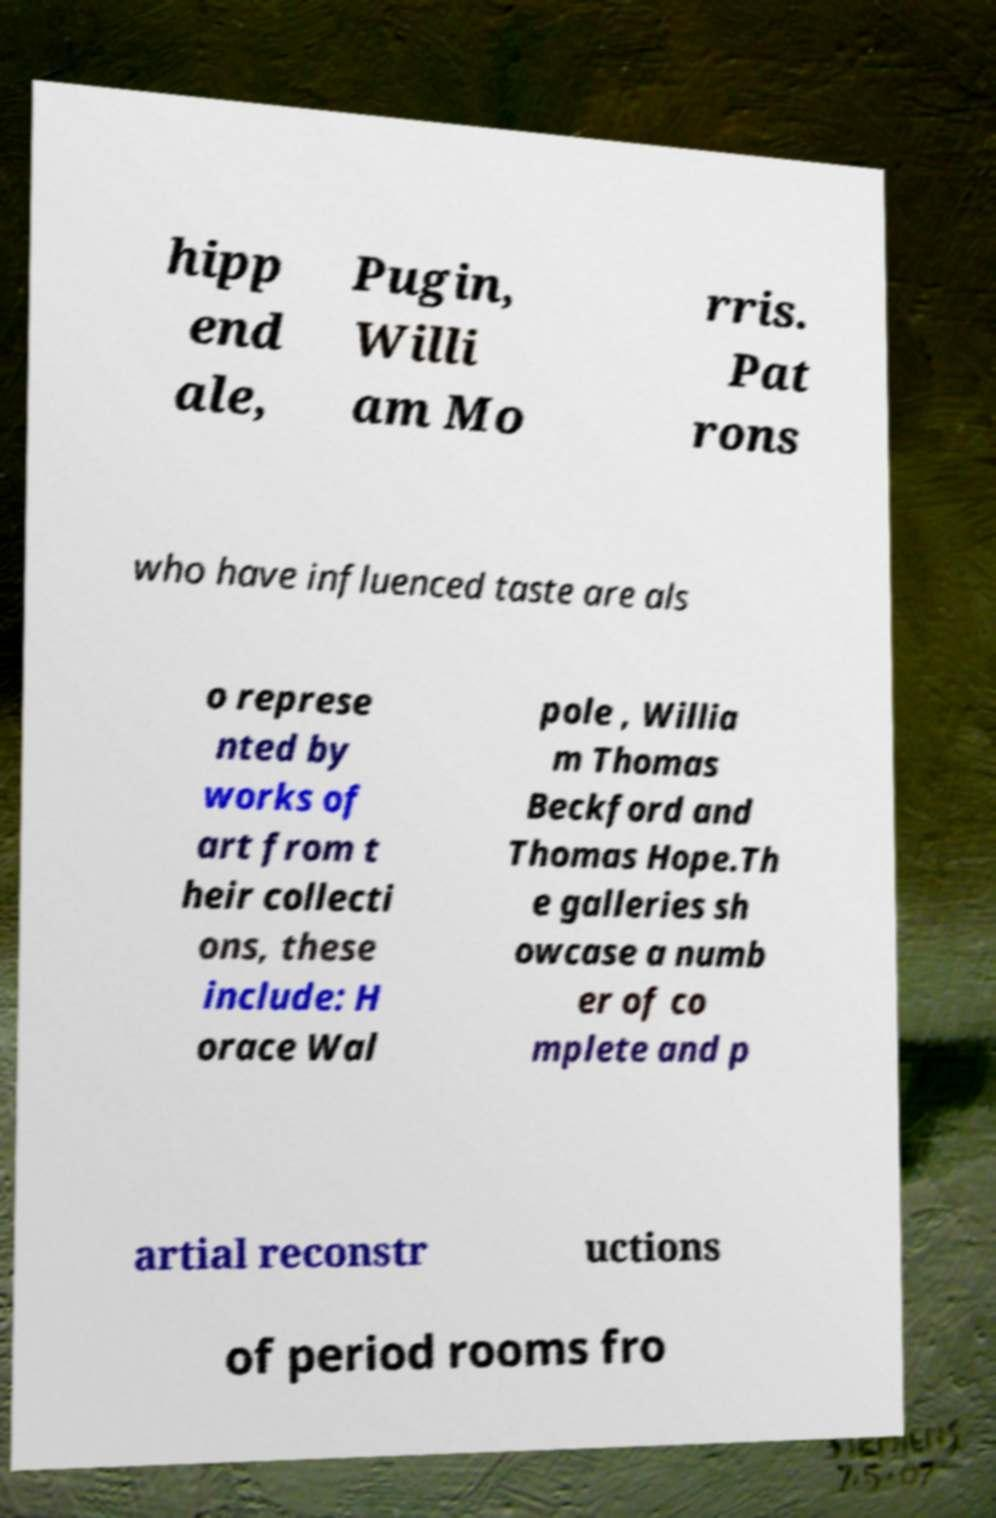Please identify and transcribe the text found in this image. hipp end ale, Pugin, Willi am Mo rris. Pat rons who have influenced taste are als o represe nted by works of art from t heir collecti ons, these include: H orace Wal pole , Willia m Thomas Beckford and Thomas Hope.Th e galleries sh owcase a numb er of co mplete and p artial reconstr uctions of period rooms fro 